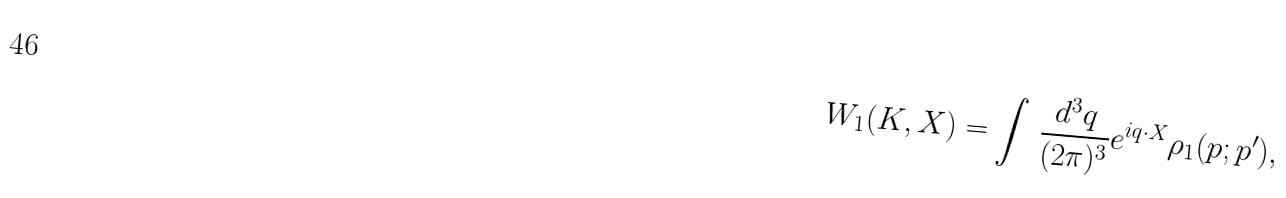<formula> <loc_0><loc_0><loc_500><loc_500>W _ { 1 } ( K , X ) = \int \, \frac { d ^ { 3 } q } { ( 2 \pi ) ^ { 3 } } e ^ { i q \cdot X } \rho _ { 1 } ( p ; p ^ { \prime } ) ,</formula> 